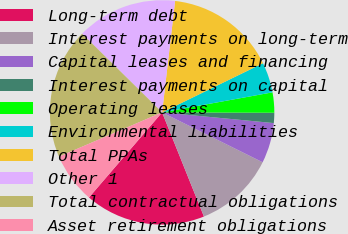<chart> <loc_0><loc_0><loc_500><loc_500><pie_chart><fcel>Long-term debt<fcel>Interest payments on long-term<fcel>Capital leases and financing<fcel>Interest payments on capital<fcel>Operating leases<fcel>Environmental liabilities<fcel>Total PPAs<fcel>Other 1<fcel>Total contractual obligations<fcel>Asset retirement obligations<nl><fcel>17.38%<fcel>11.59%<fcel>5.81%<fcel>1.47%<fcel>2.91%<fcel>4.36%<fcel>15.93%<fcel>14.48%<fcel>18.82%<fcel>7.25%<nl></chart> 